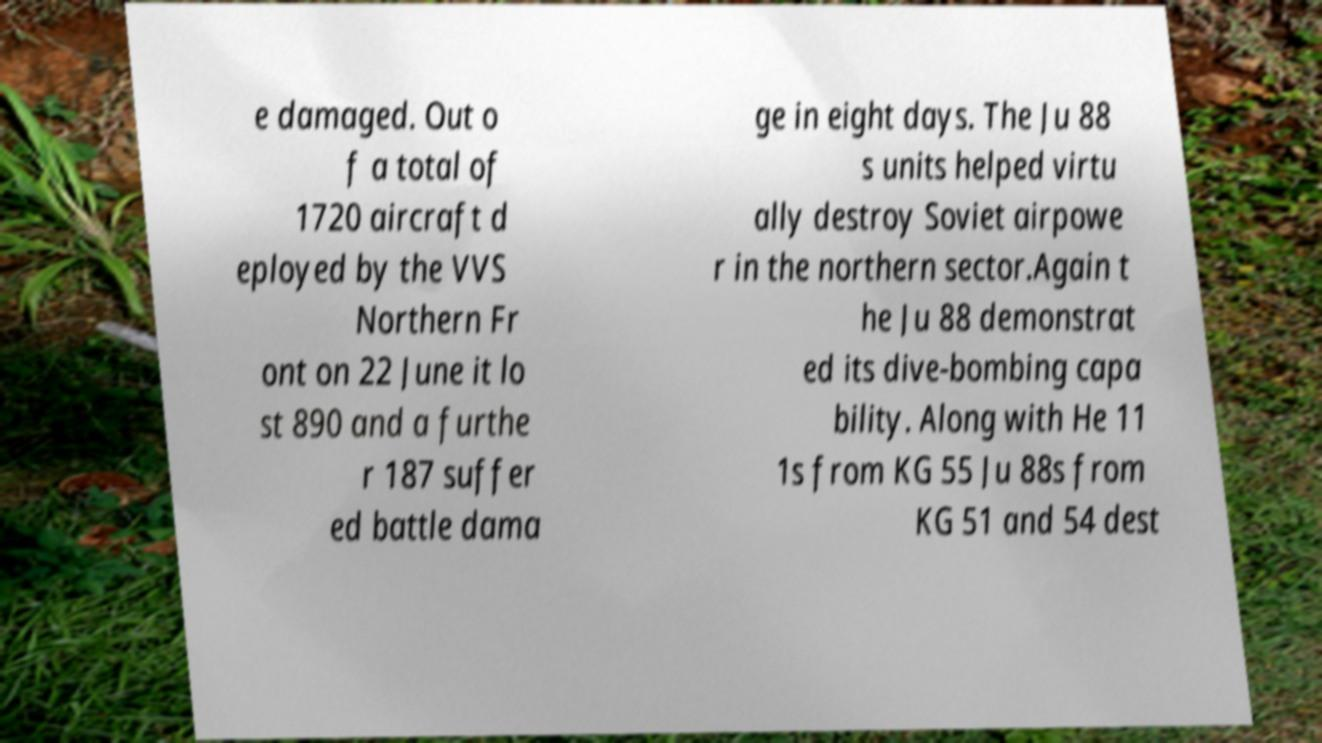What messages or text are displayed in this image? I need them in a readable, typed format. e damaged. Out o f a total of 1720 aircraft d eployed by the VVS Northern Fr ont on 22 June it lo st 890 and a furthe r 187 suffer ed battle dama ge in eight days. The Ju 88 s units helped virtu ally destroy Soviet airpowe r in the northern sector.Again t he Ju 88 demonstrat ed its dive-bombing capa bility. Along with He 11 1s from KG 55 Ju 88s from KG 51 and 54 dest 